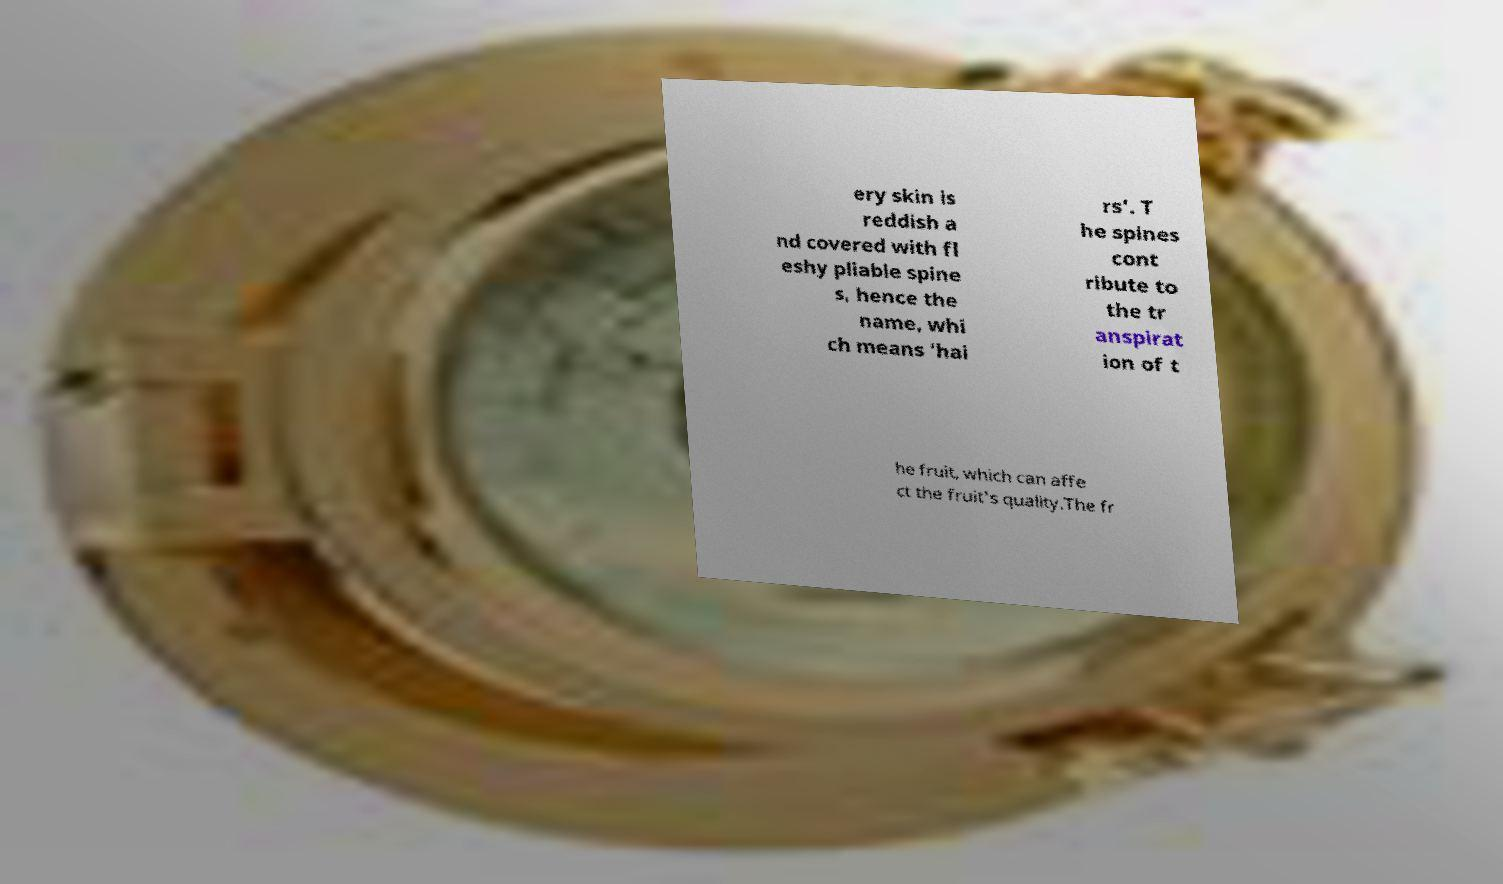Could you assist in decoding the text presented in this image and type it out clearly? ery skin is reddish a nd covered with fl eshy pliable spine s, hence the name, whi ch means 'hai rs'. T he spines cont ribute to the tr anspirat ion of t he fruit, which can affe ct the fruit's quality.The fr 